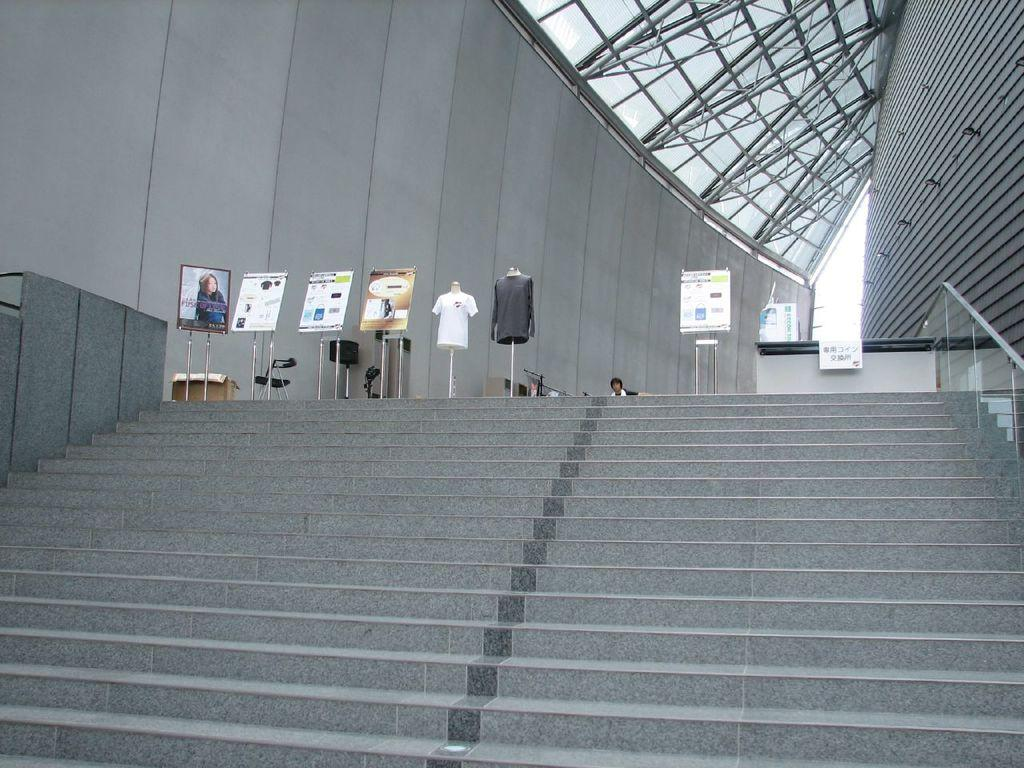What type of structure is visible in the image? There are stairs and boards visible in the image. What else can be seen in the image besides the structure? There are clothes and a person visible in the image. What type of farm animals can be seen in the image? There are no farm animals present in the image. What type of parent is the person in the image? The provided facts do not give any information about the person's role as a parent. 